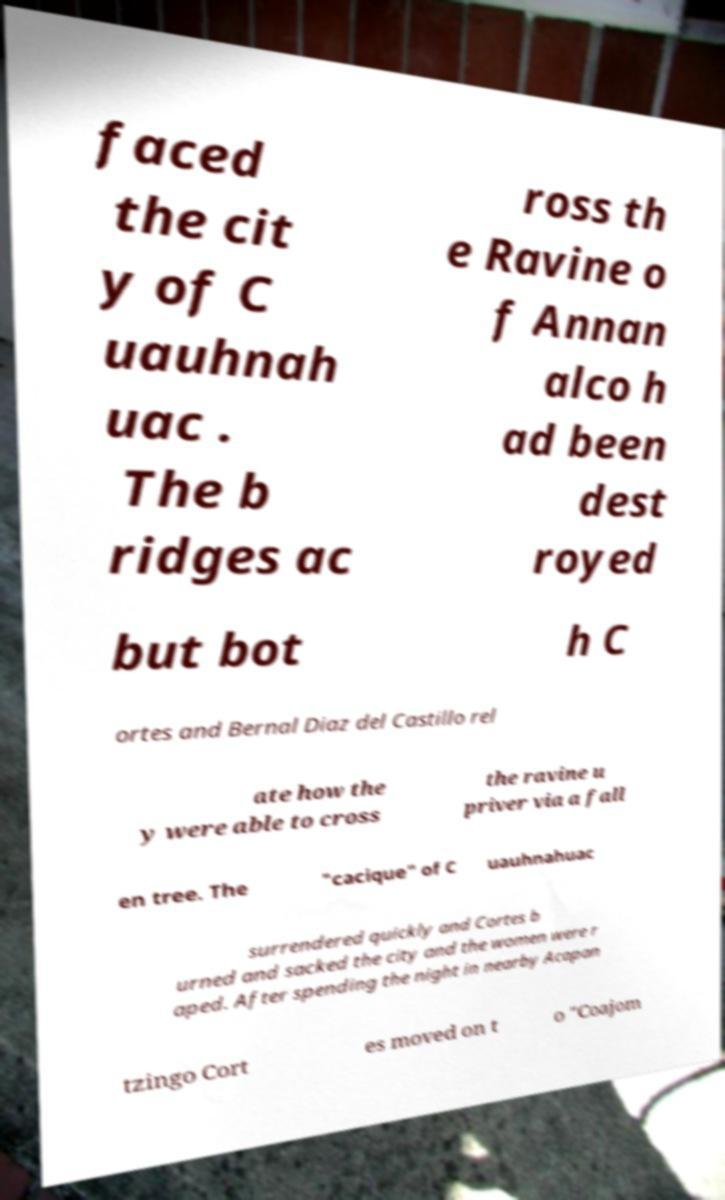What messages or text are displayed in this image? I need them in a readable, typed format. faced the cit y of C uauhnah uac . The b ridges ac ross th e Ravine o f Annan alco h ad been dest royed but bot h C ortes and Bernal Diaz del Castillo rel ate how the y were able to cross the ravine u priver via a fall en tree. The "cacique" of C uauhnahuac surrendered quickly and Cortes b urned and sacked the city and the women were r aped. After spending the night in nearby Acapan tzingo Cort es moved on t o "Coajom 